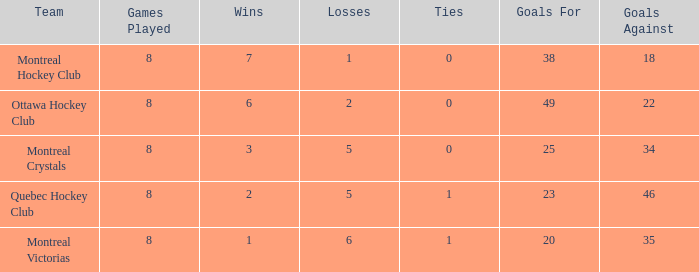What is the highest goals against when the wins is less than 1? None. 